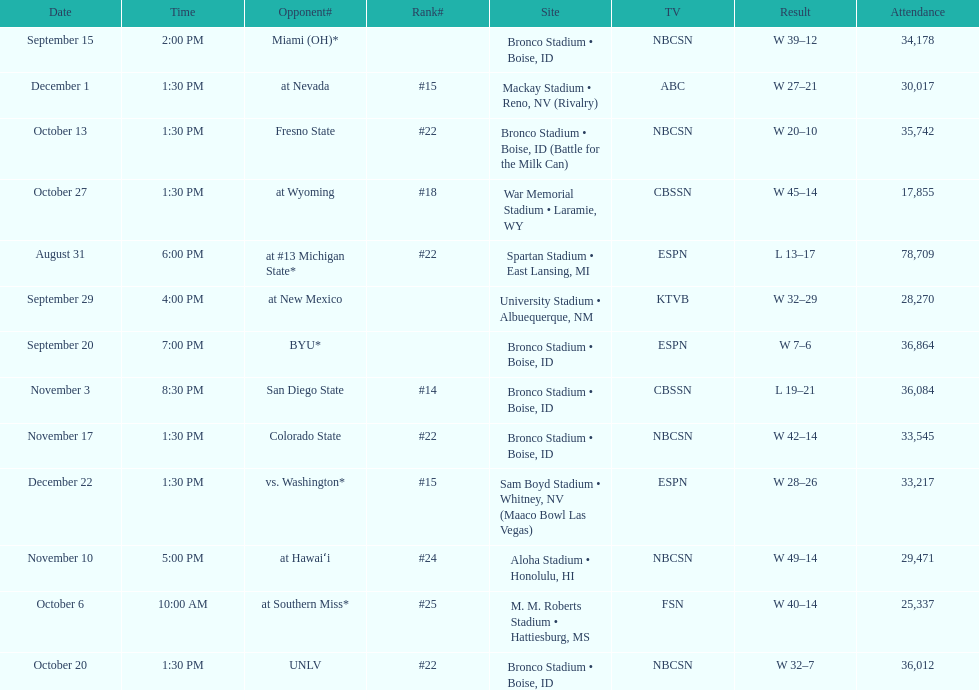Could you help me parse every detail presented in this table? {'header': ['Date', 'Time', 'Opponent#', 'Rank#', 'Site', 'TV', 'Result', 'Attendance'], 'rows': [['September 15', '2:00 PM', 'Miami (OH)*', '', 'Bronco Stadium • Boise, ID', 'NBCSN', 'W\xa039–12', '34,178'], ['December 1', '1:30 PM', 'at\xa0Nevada', '#15', 'Mackay Stadium • Reno, NV (Rivalry)', 'ABC', 'W\xa027–21', '30,017'], ['October 13', '1:30 PM', 'Fresno State', '#22', 'Bronco Stadium • Boise, ID (Battle for the Milk Can)', 'NBCSN', 'W\xa020–10', '35,742'], ['October 27', '1:30 PM', 'at\xa0Wyoming', '#18', 'War Memorial Stadium • Laramie, WY', 'CBSSN', 'W\xa045–14', '17,855'], ['August 31', '6:00 PM', 'at\xa0#13\xa0Michigan State*', '#22', 'Spartan Stadium • East Lansing, MI', 'ESPN', 'L\xa013–17', '78,709'], ['September 29', '4:00 PM', 'at\xa0New Mexico', '', 'University Stadium • Albuequerque, NM', 'KTVB', 'W\xa032–29', '28,270'], ['September 20', '7:00 PM', 'BYU*', '', 'Bronco Stadium • Boise, ID', 'ESPN', 'W\xa07–6', '36,864'], ['November 3', '8:30 PM', 'San Diego State', '#14', 'Bronco Stadium • Boise, ID', 'CBSSN', 'L\xa019–21', '36,084'], ['November 17', '1:30 PM', 'Colorado State', '#22', 'Bronco Stadium • Boise, ID', 'NBCSN', 'W\xa042–14', '33,545'], ['December 22', '1:30 PM', 'vs.\xa0Washington*', '#15', 'Sam Boyd Stadium • Whitney, NV (Maaco Bowl Las Vegas)', 'ESPN', 'W\xa028–26', '33,217'], ['November 10', '5:00 PM', 'at\xa0Hawaiʻi', '#24', 'Aloha Stadium • Honolulu, HI', 'NBCSN', 'W\xa049–14', '29,471'], ['October 6', '10:00 AM', 'at\xa0Southern Miss*', '#25', 'M. M. Roberts Stadium • Hattiesburg, MS', 'FSN', 'W\xa040–14', '25,337'], ['October 20', '1:30 PM', 'UNLV', '#22', 'Bronco Stadium • Boise, ID', 'NBCSN', 'W\xa032–7', '36,012']]} What is the score difference for the game against michigan state? 4. 